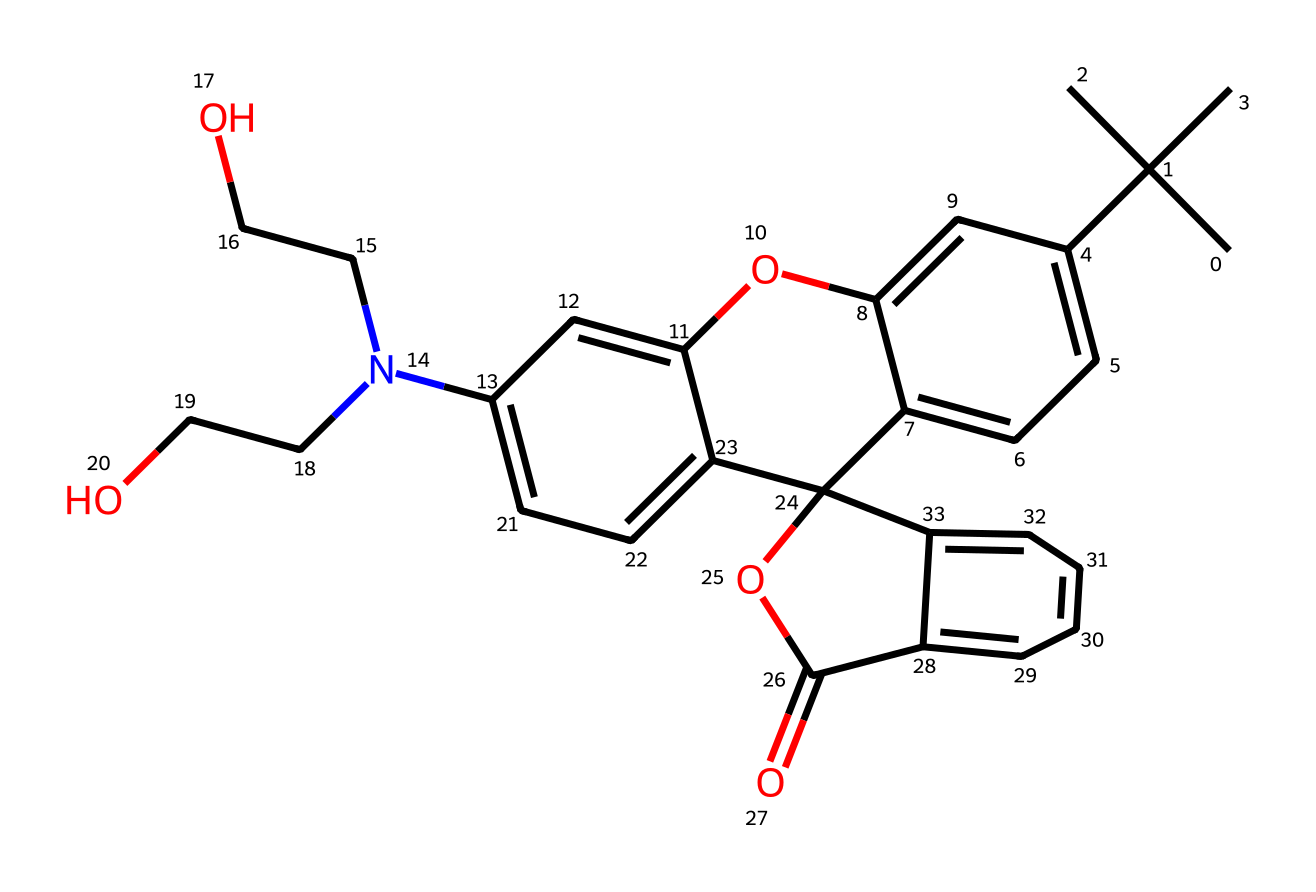What is the name of the dye represented by this structure? The SMILES representation corresponds to the chemical structure of rhodamine B, which is commonly used as a dye, particularly in forensic analysis.
Answer: rhodamine B How many aromatic rings are present in the structure of this dye? By examining the structure, we can identify two distinct aromatic rings based on the cyclic nature of the carbon atoms and the presence of alternating double bonds.
Answer: 2 What functional group is present that indicates this dye can form hydrogen bonds? The presence of -NH (amine group) in the structure suggests that it can participate in hydrogen bonding, a characteristic that is useful in various chemical interactions.
Answer: amine How many hydroxyl (-OH) groups are present in rhodamine B? By closely analyzing the structure, there are two hydroxyl groups (-OH) attached to the carbon chain, which are indicated in the SMILES representation.
Answer: 2 What is the overall charge of rhodamine B at physiological pH? The structure can be interpreted such that there are no formal positive or negative charges apparent in the structure under physiological pH conditions, indicating it is neutral overall.
Answer: neutral What type of chemical reaction would this dye most likely undergo in an acidic environment? In an acidic environment, the amine group (-NH) can be protonated, leading to possible formation of a positively charged species, specifically a quaternary ammonium.
Answer: protonation 